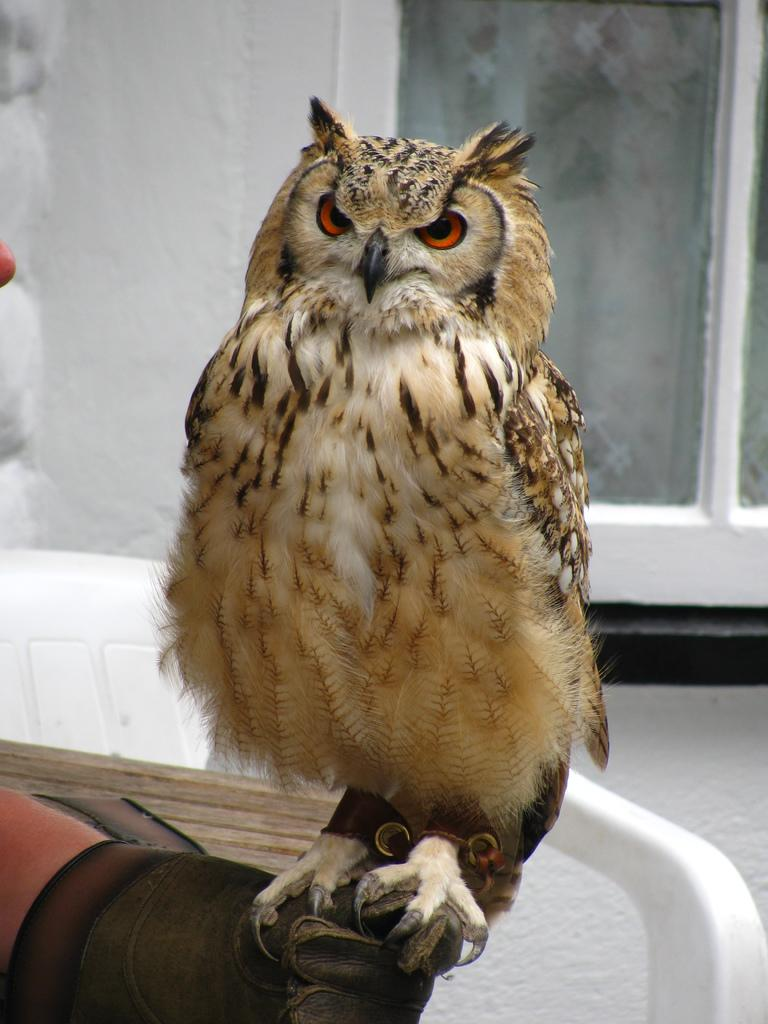What is the person in the image doing? The person is holding a bird in the image. What objects can be seen in the background of the image? There is a chair, a table, and a window in the background of the image. How does the person use the hose to smash the tax in the image? There is no hose, smashing, or tax present in the image. 